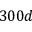Convert formula to latex. <formula><loc_0><loc_0><loc_500><loc_500>3 0 0 d</formula> 